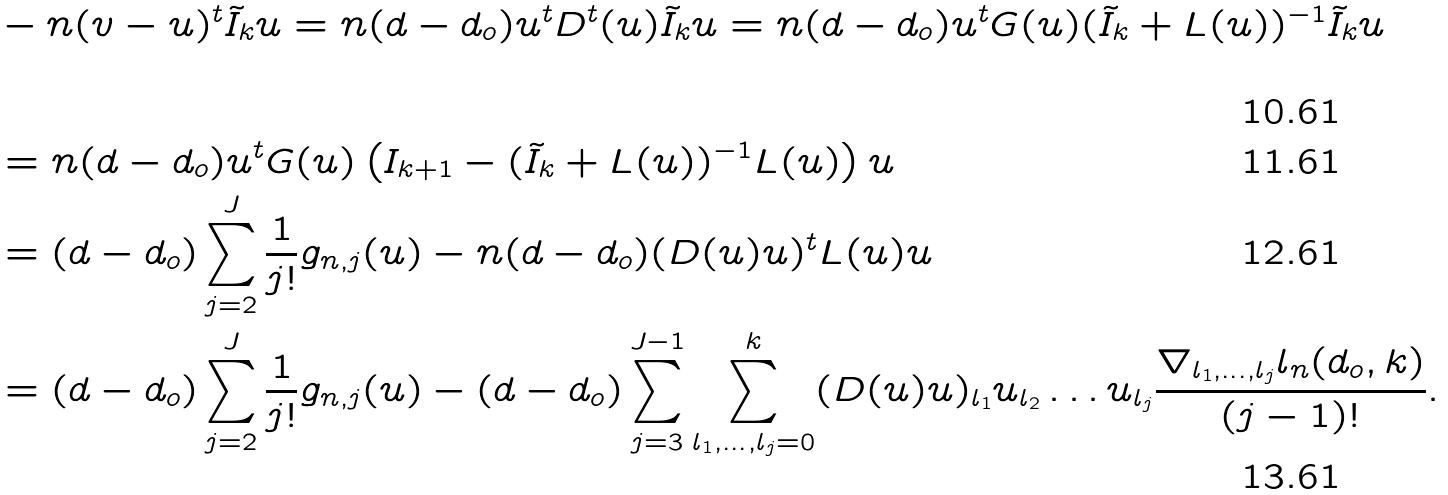<formula> <loc_0><loc_0><loc_500><loc_500>& - n ( v - u ) ^ { t } \tilde { I } _ { k } u = n ( d - d _ { o } ) u ^ { t } D ^ { t } ( u ) \tilde { I } _ { k } u = n ( d - d _ { o } ) u ^ { t } G ( u ) ( \tilde { I } _ { k } + L ( u ) ) ^ { - 1 } \tilde { I } _ { k } u \\ & = n ( d - d _ { o } ) u ^ { t } G ( u ) \left ( I _ { k + 1 } - ( \tilde { I } _ { k } + L ( u ) ) ^ { - 1 } L ( u ) \right ) u \\ & = ( d - d _ { o } ) \sum _ { j = 2 } ^ { J } \frac { 1 } { j ! } g _ { n , j } ( u ) - n ( d - d _ { o } ) ( D ( u ) u ) ^ { t } L ( u ) u \\ & = ( d - d _ { o } ) \sum _ { j = 2 } ^ { J } \frac { 1 } { j ! } g _ { n , j } ( u ) - ( d - d _ { o } ) \sum _ { j = 3 } ^ { J - 1 } \sum _ { l _ { 1 } , \dots , l _ { j } = 0 } ^ { k } ( D ( u ) u ) _ { l _ { 1 } } u _ { l _ { 2 } } \dots u _ { l _ { j } } \frac { \nabla _ { l _ { 1 } , \dots , l _ { j } } l _ { n } ( d _ { o } , k ) } { ( j - 1 ) ! } .</formula> 